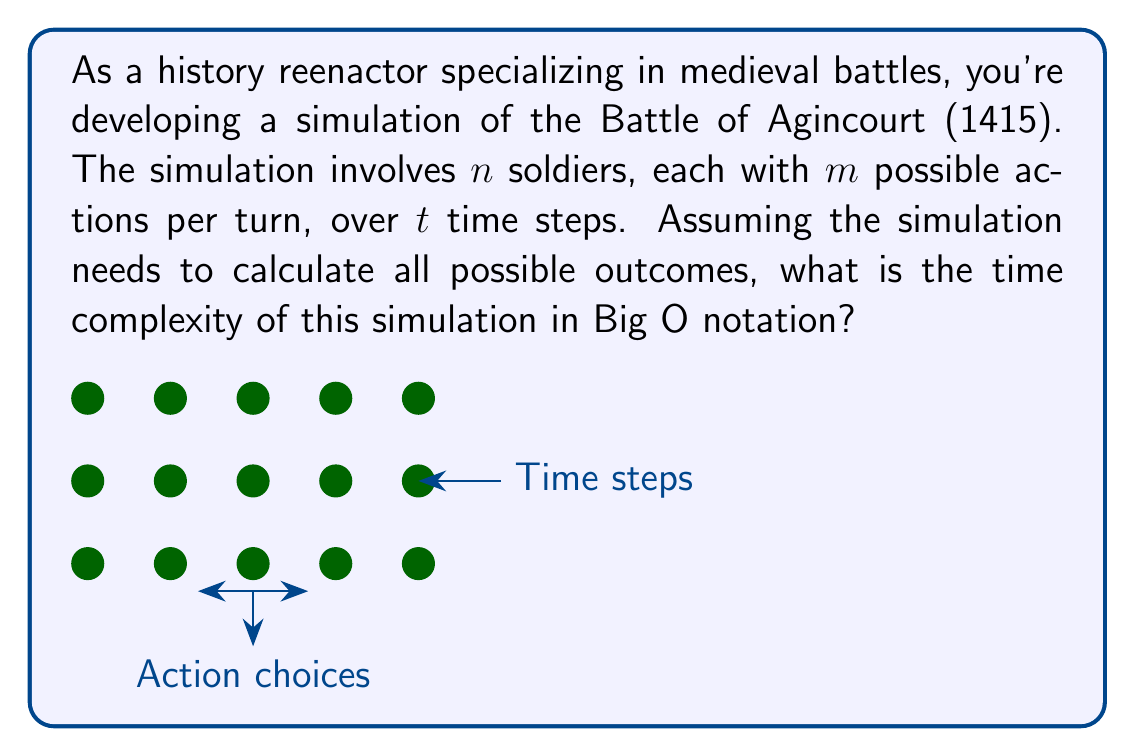Solve this math problem. To analyze the computational complexity of this historical battle simulation, let's break it down step-by-step:

1) For each time step, every soldier must choose an action.

2) There are $n$ soldiers, each with $m$ possible actions.

3) The number of possible combinations of actions for all soldiers in a single time step is $m^n$.

4) This process is repeated for each of the $t$ time steps.

5) Therefore, the total number of possible outcomes (action combinations) over the entire simulation is $(m^n)^t$.

6) Simplifying the exponent: $(m^n)^t = m^{nt}$

7) In terms of computational complexity, we need to consider the number of operations required to calculate all these outcomes.

8) The number of operations is directly proportional to the number of outcomes, so the time complexity is $O(m^{nt})$.

9) This is an exponential time complexity, which is extremely high and practically infeasible for large values of $n$, $m$, or $t$.

In the context of simulating the Battle of Agincourt, this complexity demonstrates why full simulations of historical battles are computationally intensive and often require simplifications or approximations to be practically computable.
Answer: $O(m^{nt})$ 